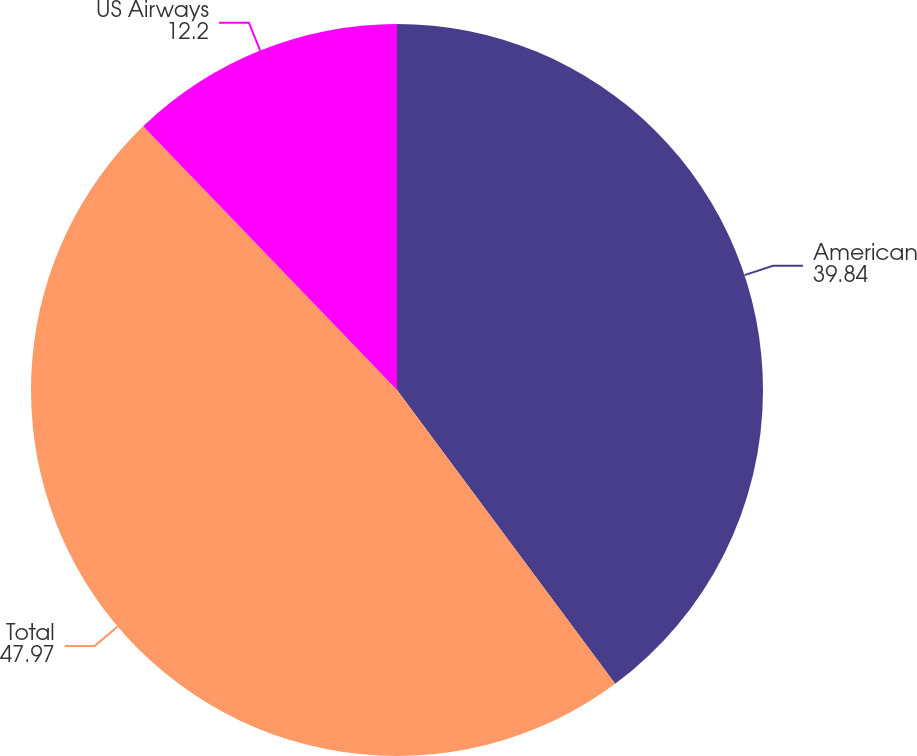Convert chart to OTSL. <chart><loc_0><loc_0><loc_500><loc_500><pie_chart><fcel>American<fcel>Total<fcel>US Airways<nl><fcel>39.84%<fcel>47.97%<fcel>12.2%<nl></chart> 